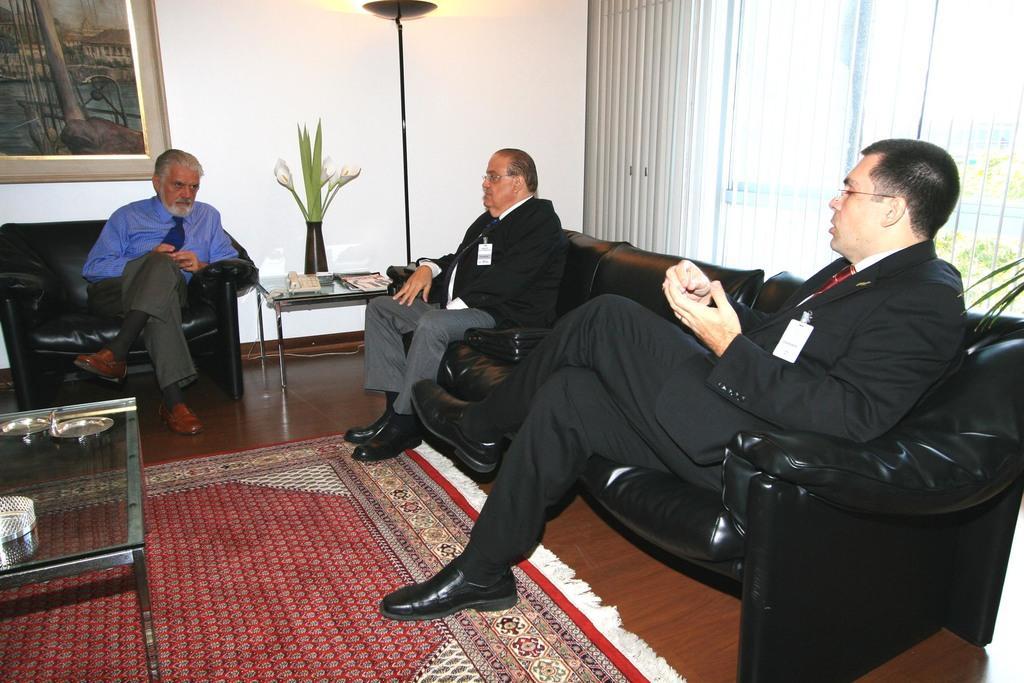In one or two sentences, can you explain what this image depicts? In the picture we can see a man sitting in the sofa chair which is black in color, he is with blue shirt, tie and white beard and near him we can see two men are sitting in the sofa, they are in blazers, ties and ID cards and on the floor we can see a mat with some designs on it and on it we can see a glass table and some things on it and beside the man we can see a table with flower pot with some flowers and leaves in it and to the wall we can see a photo frame with painting. 